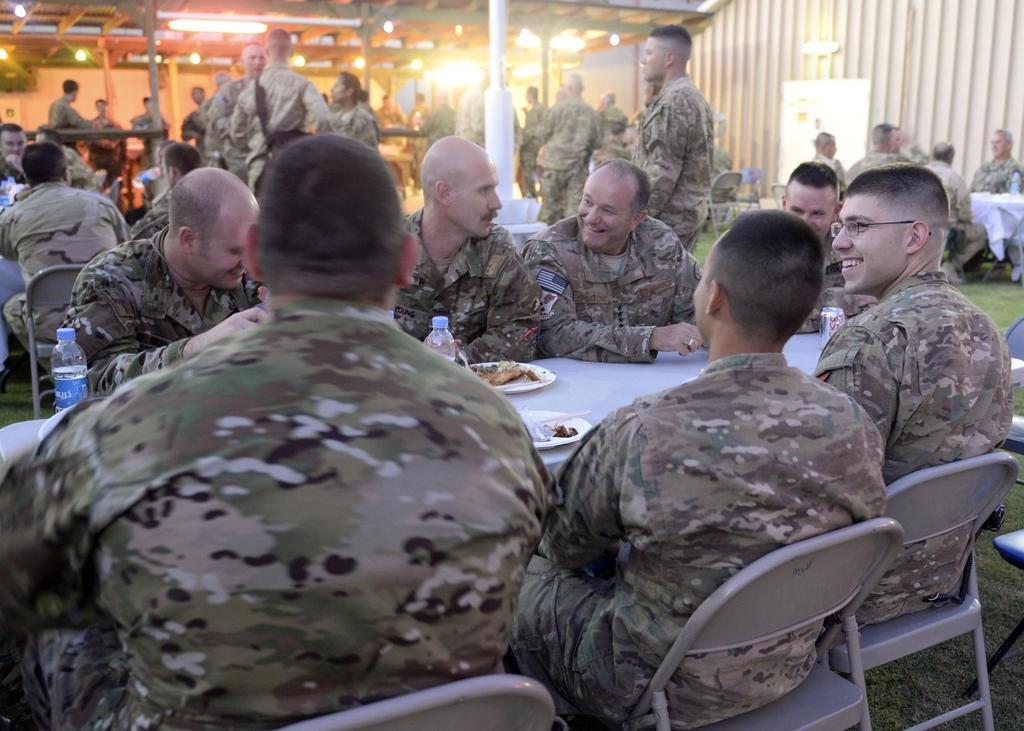Can you describe this image briefly? In this image i can see group of people some are standing and some are sitting wearing military uniform. I can also see a table and chairs on the table there is a food and two bottles ,at back i can see a shed and lights attached to it there is a pole, on the ground there is grass. 